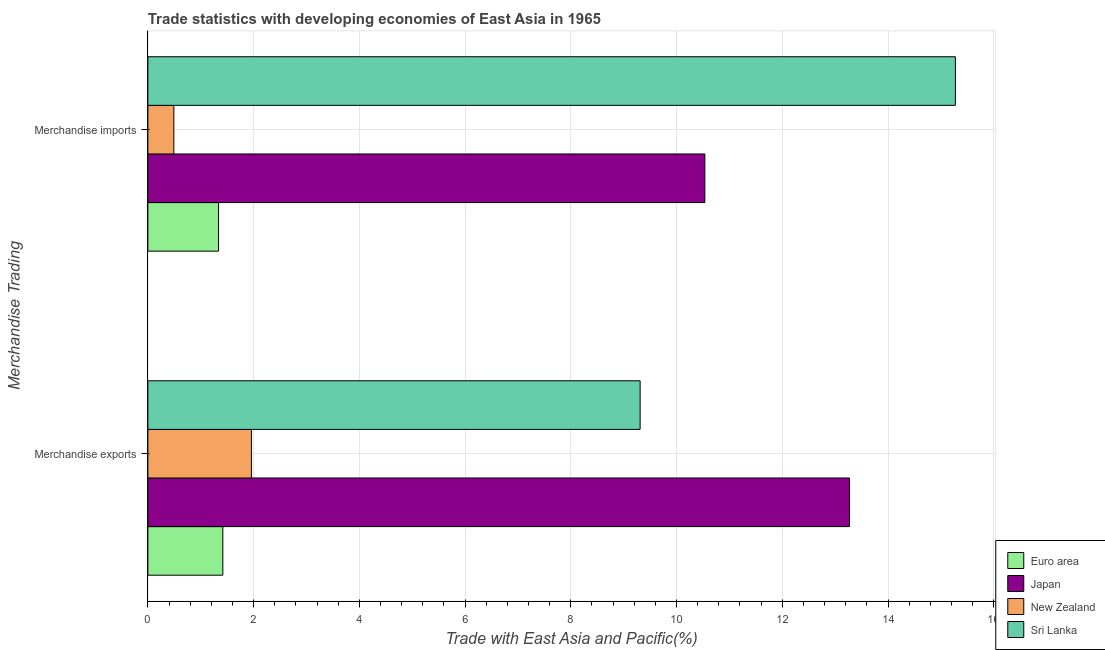How many different coloured bars are there?
Your answer should be very brief. 4. How many groups of bars are there?
Offer a terse response. 2. Are the number of bars per tick equal to the number of legend labels?
Your response must be concise. Yes. How many bars are there on the 2nd tick from the top?
Offer a terse response. 4. How many bars are there on the 1st tick from the bottom?
Your answer should be compact. 4. What is the label of the 1st group of bars from the top?
Provide a short and direct response. Merchandise imports. What is the merchandise exports in Sri Lanka?
Keep it short and to the point. 9.31. Across all countries, what is the maximum merchandise exports?
Offer a terse response. 13.27. Across all countries, what is the minimum merchandise imports?
Ensure brevity in your answer.  0.49. What is the total merchandise exports in the graph?
Give a very brief answer. 25.96. What is the difference between the merchandise imports in New Zealand and that in Euro area?
Offer a very short reply. -0.85. What is the difference between the merchandise imports in New Zealand and the merchandise exports in Japan?
Give a very brief answer. -12.78. What is the average merchandise exports per country?
Provide a short and direct response. 6.49. What is the difference between the merchandise exports and merchandise imports in Sri Lanka?
Ensure brevity in your answer.  -5.96. What is the ratio of the merchandise imports in Japan to that in Sri Lanka?
Make the answer very short. 0.69. What does the 4th bar from the top in Merchandise imports represents?
Give a very brief answer. Euro area. What does the 3rd bar from the bottom in Merchandise imports represents?
Offer a terse response. New Zealand. What is the difference between two consecutive major ticks on the X-axis?
Your answer should be very brief. 2. Does the graph contain any zero values?
Your answer should be compact. No. How many legend labels are there?
Provide a succinct answer. 4. What is the title of the graph?
Your response must be concise. Trade statistics with developing economies of East Asia in 1965. What is the label or title of the X-axis?
Offer a very short reply. Trade with East Asia and Pacific(%). What is the label or title of the Y-axis?
Provide a short and direct response. Merchandise Trading. What is the Trade with East Asia and Pacific(%) of Euro area in Merchandise exports?
Keep it short and to the point. 1.42. What is the Trade with East Asia and Pacific(%) of Japan in Merchandise exports?
Your answer should be very brief. 13.27. What is the Trade with East Asia and Pacific(%) in New Zealand in Merchandise exports?
Make the answer very short. 1.96. What is the Trade with East Asia and Pacific(%) of Sri Lanka in Merchandise exports?
Provide a short and direct response. 9.31. What is the Trade with East Asia and Pacific(%) in Euro area in Merchandise imports?
Make the answer very short. 1.34. What is the Trade with East Asia and Pacific(%) in Japan in Merchandise imports?
Offer a very short reply. 10.54. What is the Trade with East Asia and Pacific(%) of New Zealand in Merchandise imports?
Provide a succinct answer. 0.49. What is the Trade with East Asia and Pacific(%) of Sri Lanka in Merchandise imports?
Offer a terse response. 15.27. Across all Merchandise Trading, what is the maximum Trade with East Asia and Pacific(%) of Euro area?
Your answer should be very brief. 1.42. Across all Merchandise Trading, what is the maximum Trade with East Asia and Pacific(%) in Japan?
Your answer should be very brief. 13.27. Across all Merchandise Trading, what is the maximum Trade with East Asia and Pacific(%) in New Zealand?
Make the answer very short. 1.96. Across all Merchandise Trading, what is the maximum Trade with East Asia and Pacific(%) of Sri Lanka?
Provide a succinct answer. 15.27. Across all Merchandise Trading, what is the minimum Trade with East Asia and Pacific(%) in Euro area?
Give a very brief answer. 1.34. Across all Merchandise Trading, what is the minimum Trade with East Asia and Pacific(%) of Japan?
Your response must be concise. 10.54. Across all Merchandise Trading, what is the minimum Trade with East Asia and Pacific(%) in New Zealand?
Offer a terse response. 0.49. Across all Merchandise Trading, what is the minimum Trade with East Asia and Pacific(%) in Sri Lanka?
Offer a terse response. 9.31. What is the total Trade with East Asia and Pacific(%) in Euro area in the graph?
Ensure brevity in your answer.  2.76. What is the total Trade with East Asia and Pacific(%) in Japan in the graph?
Offer a very short reply. 23.81. What is the total Trade with East Asia and Pacific(%) in New Zealand in the graph?
Your answer should be very brief. 2.45. What is the total Trade with East Asia and Pacific(%) of Sri Lanka in the graph?
Keep it short and to the point. 24.59. What is the difference between the Trade with East Asia and Pacific(%) in Euro area in Merchandise exports and that in Merchandise imports?
Provide a succinct answer. 0.08. What is the difference between the Trade with East Asia and Pacific(%) of Japan in Merchandise exports and that in Merchandise imports?
Offer a very short reply. 2.74. What is the difference between the Trade with East Asia and Pacific(%) in New Zealand in Merchandise exports and that in Merchandise imports?
Your answer should be compact. 1.47. What is the difference between the Trade with East Asia and Pacific(%) in Sri Lanka in Merchandise exports and that in Merchandise imports?
Your response must be concise. -5.96. What is the difference between the Trade with East Asia and Pacific(%) of Euro area in Merchandise exports and the Trade with East Asia and Pacific(%) of Japan in Merchandise imports?
Give a very brief answer. -9.12. What is the difference between the Trade with East Asia and Pacific(%) of Euro area in Merchandise exports and the Trade with East Asia and Pacific(%) of New Zealand in Merchandise imports?
Make the answer very short. 0.93. What is the difference between the Trade with East Asia and Pacific(%) of Euro area in Merchandise exports and the Trade with East Asia and Pacific(%) of Sri Lanka in Merchandise imports?
Give a very brief answer. -13.86. What is the difference between the Trade with East Asia and Pacific(%) of Japan in Merchandise exports and the Trade with East Asia and Pacific(%) of New Zealand in Merchandise imports?
Give a very brief answer. 12.78. What is the difference between the Trade with East Asia and Pacific(%) in Japan in Merchandise exports and the Trade with East Asia and Pacific(%) in Sri Lanka in Merchandise imports?
Keep it short and to the point. -2. What is the difference between the Trade with East Asia and Pacific(%) of New Zealand in Merchandise exports and the Trade with East Asia and Pacific(%) of Sri Lanka in Merchandise imports?
Give a very brief answer. -13.32. What is the average Trade with East Asia and Pacific(%) in Euro area per Merchandise Trading?
Keep it short and to the point. 1.38. What is the average Trade with East Asia and Pacific(%) in Japan per Merchandise Trading?
Keep it short and to the point. 11.9. What is the average Trade with East Asia and Pacific(%) in New Zealand per Merchandise Trading?
Ensure brevity in your answer.  1.23. What is the average Trade with East Asia and Pacific(%) in Sri Lanka per Merchandise Trading?
Make the answer very short. 12.29. What is the difference between the Trade with East Asia and Pacific(%) in Euro area and Trade with East Asia and Pacific(%) in Japan in Merchandise exports?
Give a very brief answer. -11.85. What is the difference between the Trade with East Asia and Pacific(%) of Euro area and Trade with East Asia and Pacific(%) of New Zealand in Merchandise exports?
Provide a short and direct response. -0.54. What is the difference between the Trade with East Asia and Pacific(%) in Euro area and Trade with East Asia and Pacific(%) in Sri Lanka in Merchandise exports?
Provide a succinct answer. -7.89. What is the difference between the Trade with East Asia and Pacific(%) in Japan and Trade with East Asia and Pacific(%) in New Zealand in Merchandise exports?
Provide a succinct answer. 11.31. What is the difference between the Trade with East Asia and Pacific(%) in Japan and Trade with East Asia and Pacific(%) in Sri Lanka in Merchandise exports?
Your answer should be compact. 3.96. What is the difference between the Trade with East Asia and Pacific(%) in New Zealand and Trade with East Asia and Pacific(%) in Sri Lanka in Merchandise exports?
Give a very brief answer. -7.35. What is the difference between the Trade with East Asia and Pacific(%) of Euro area and Trade with East Asia and Pacific(%) of Japan in Merchandise imports?
Offer a terse response. -9.2. What is the difference between the Trade with East Asia and Pacific(%) in Euro area and Trade with East Asia and Pacific(%) in New Zealand in Merchandise imports?
Your response must be concise. 0.85. What is the difference between the Trade with East Asia and Pacific(%) of Euro area and Trade with East Asia and Pacific(%) of Sri Lanka in Merchandise imports?
Keep it short and to the point. -13.94. What is the difference between the Trade with East Asia and Pacific(%) in Japan and Trade with East Asia and Pacific(%) in New Zealand in Merchandise imports?
Provide a succinct answer. 10.04. What is the difference between the Trade with East Asia and Pacific(%) of Japan and Trade with East Asia and Pacific(%) of Sri Lanka in Merchandise imports?
Your answer should be compact. -4.74. What is the difference between the Trade with East Asia and Pacific(%) of New Zealand and Trade with East Asia and Pacific(%) of Sri Lanka in Merchandise imports?
Make the answer very short. -14.78. What is the ratio of the Trade with East Asia and Pacific(%) of Euro area in Merchandise exports to that in Merchandise imports?
Make the answer very short. 1.06. What is the ratio of the Trade with East Asia and Pacific(%) of Japan in Merchandise exports to that in Merchandise imports?
Provide a short and direct response. 1.26. What is the ratio of the Trade with East Asia and Pacific(%) in New Zealand in Merchandise exports to that in Merchandise imports?
Ensure brevity in your answer.  3.99. What is the ratio of the Trade with East Asia and Pacific(%) in Sri Lanka in Merchandise exports to that in Merchandise imports?
Ensure brevity in your answer.  0.61. What is the difference between the highest and the second highest Trade with East Asia and Pacific(%) of Euro area?
Your answer should be very brief. 0.08. What is the difference between the highest and the second highest Trade with East Asia and Pacific(%) of Japan?
Offer a terse response. 2.74. What is the difference between the highest and the second highest Trade with East Asia and Pacific(%) of New Zealand?
Provide a short and direct response. 1.47. What is the difference between the highest and the second highest Trade with East Asia and Pacific(%) of Sri Lanka?
Provide a short and direct response. 5.96. What is the difference between the highest and the lowest Trade with East Asia and Pacific(%) of Euro area?
Keep it short and to the point. 0.08. What is the difference between the highest and the lowest Trade with East Asia and Pacific(%) in Japan?
Provide a succinct answer. 2.74. What is the difference between the highest and the lowest Trade with East Asia and Pacific(%) in New Zealand?
Provide a short and direct response. 1.47. What is the difference between the highest and the lowest Trade with East Asia and Pacific(%) of Sri Lanka?
Your answer should be compact. 5.96. 